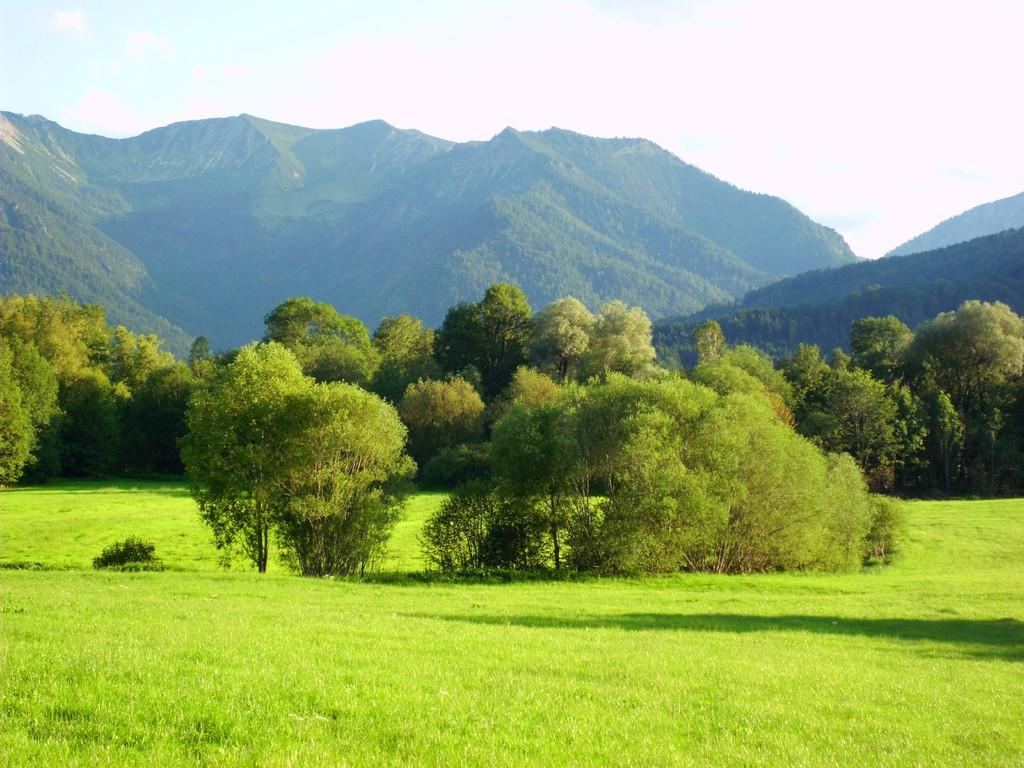What type of vegetation is present in the image? There are many trees in the image. What is the ground covered with in the image? There is green grass at the bottom of the image. What can be seen in the distance in the image? There are mountains in the background of the image. What is visible at the top of the image? The sky is visible at the top of the image. Can you see a veil hanging from one of the trees in the image? There is no veil present in the image; it features trees, green grass, mountains, and the sky. What date is marked on the calendar in the image? There is no calendar present in the image. 